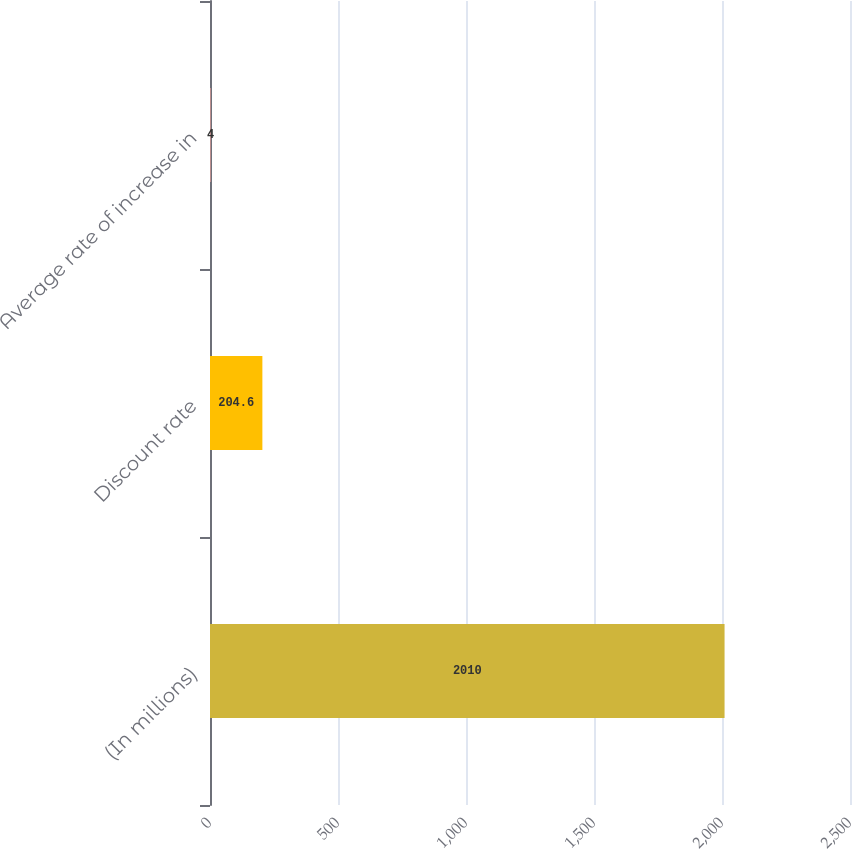Convert chart. <chart><loc_0><loc_0><loc_500><loc_500><bar_chart><fcel>(In millions)<fcel>Discount rate<fcel>Average rate of increase in<nl><fcel>2010<fcel>204.6<fcel>4<nl></chart> 